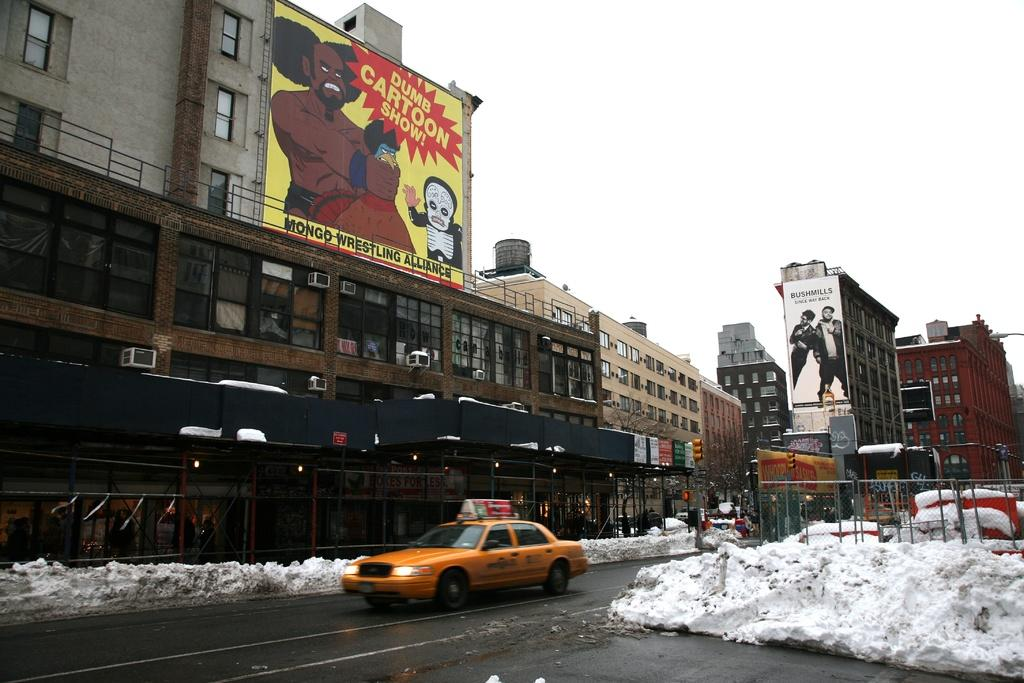<image>
Present a compact description of the photo's key features. a sign for a dumb cartoon show that is above the ground 